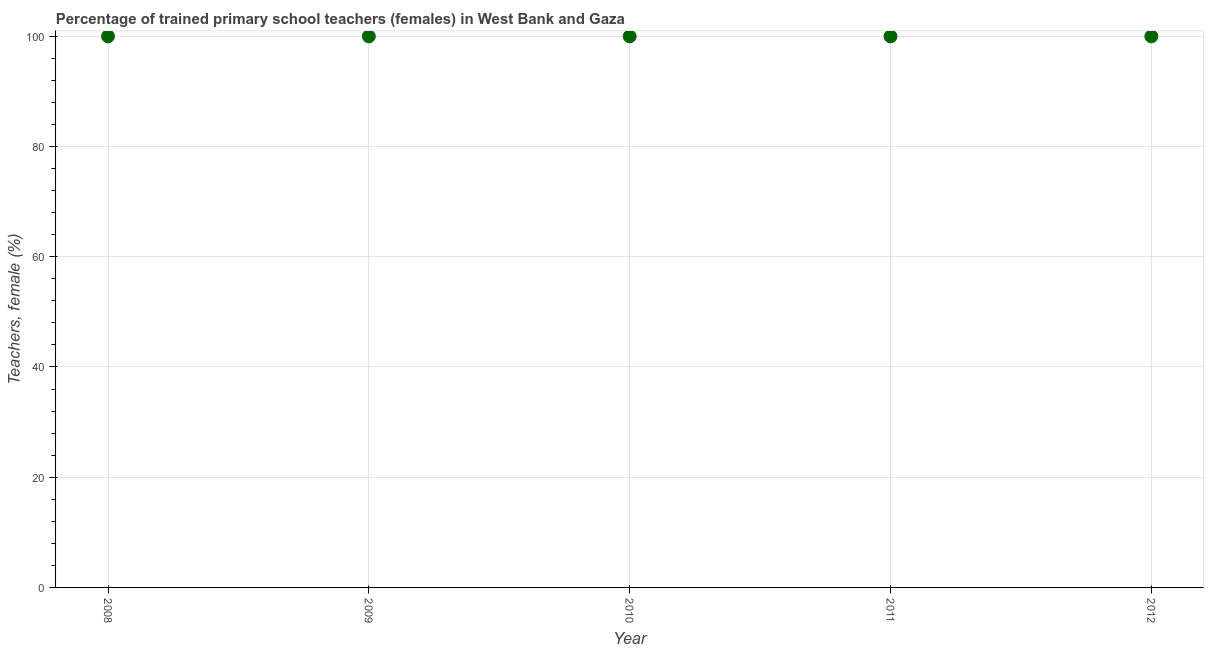What is the percentage of trained female teachers in 2010?
Your response must be concise. 100. Across all years, what is the maximum percentage of trained female teachers?
Your response must be concise. 100. Across all years, what is the minimum percentage of trained female teachers?
Offer a terse response. 100. In which year was the percentage of trained female teachers maximum?
Your answer should be very brief. 2008. In which year was the percentage of trained female teachers minimum?
Offer a very short reply. 2008. What is the sum of the percentage of trained female teachers?
Provide a succinct answer. 500. What is the difference between the percentage of trained female teachers in 2008 and 2009?
Offer a terse response. 0. What is the average percentage of trained female teachers per year?
Give a very brief answer. 100. In how many years, is the percentage of trained female teachers greater than 32 %?
Offer a terse response. 5. Do a majority of the years between 2012 and 2008 (inclusive) have percentage of trained female teachers greater than 16 %?
Your answer should be compact. Yes. Is the percentage of trained female teachers in 2011 less than that in 2012?
Offer a terse response. No. Is the sum of the percentage of trained female teachers in 2008 and 2009 greater than the maximum percentage of trained female teachers across all years?
Offer a very short reply. Yes. Does the percentage of trained female teachers monotonically increase over the years?
Offer a terse response. No. How many years are there in the graph?
Your response must be concise. 5. Are the values on the major ticks of Y-axis written in scientific E-notation?
Ensure brevity in your answer.  No. Does the graph contain any zero values?
Offer a terse response. No. What is the title of the graph?
Give a very brief answer. Percentage of trained primary school teachers (females) in West Bank and Gaza. What is the label or title of the X-axis?
Provide a short and direct response. Year. What is the label or title of the Y-axis?
Keep it short and to the point. Teachers, female (%). What is the Teachers, female (%) in 2008?
Your response must be concise. 100. What is the Teachers, female (%) in 2009?
Give a very brief answer. 100. What is the Teachers, female (%) in 2011?
Provide a short and direct response. 100. What is the Teachers, female (%) in 2012?
Your response must be concise. 100. What is the difference between the Teachers, female (%) in 2008 and 2009?
Your answer should be compact. 0. What is the difference between the Teachers, female (%) in 2008 and 2010?
Keep it short and to the point. 0. What is the difference between the Teachers, female (%) in 2008 and 2012?
Your answer should be compact. 0. What is the difference between the Teachers, female (%) in 2009 and 2010?
Your answer should be compact. 0. What is the difference between the Teachers, female (%) in 2009 and 2011?
Make the answer very short. 0. What is the difference between the Teachers, female (%) in 2010 and 2011?
Make the answer very short. 0. What is the ratio of the Teachers, female (%) in 2008 to that in 2010?
Your answer should be very brief. 1. What is the ratio of the Teachers, female (%) in 2008 to that in 2012?
Offer a terse response. 1. What is the ratio of the Teachers, female (%) in 2009 to that in 2010?
Make the answer very short. 1. What is the ratio of the Teachers, female (%) in 2009 to that in 2012?
Keep it short and to the point. 1. What is the ratio of the Teachers, female (%) in 2010 to that in 2011?
Provide a succinct answer. 1. What is the ratio of the Teachers, female (%) in 2011 to that in 2012?
Your response must be concise. 1. 